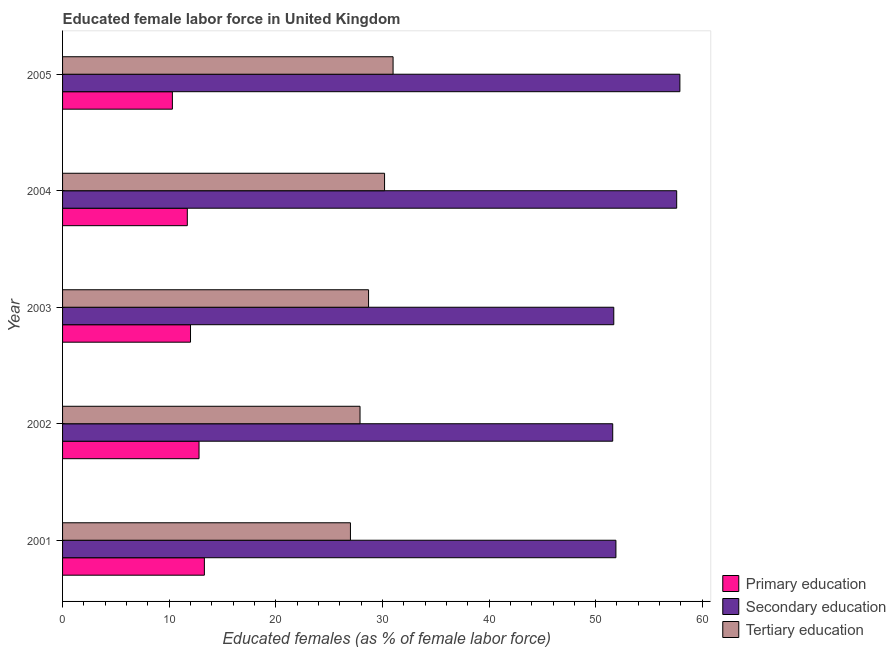How many bars are there on the 2nd tick from the top?
Provide a short and direct response. 3. In how many cases, is the number of bars for a given year not equal to the number of legend labels?
Keep it short and to the point. 0. What is the percentage of female labor force who received primary education in 2005?
Provide a succinct answer. 10.3. Across all years, what is the maximum percentage of female labor force who received secondary education?
Give a very brief answer. 57.9. Across all years, what is the minimum percentage of female labor force who received tertiary education?
Make the answer very short. 27. In which year was the percentage of female labor force who received primary education maximum?
Provide a short and direct response. 2001. In which year was the percentage of female labor force who received secondary education minimum?
Provide a short and direct response. 2002. What is the total percentage of female labor force who received tertiary education in the graph?
Provide a short and direct response. 144.8. What is the difference between the percentage of female labor force who received primary education in 2003 and the percentage of female labor force who received secondary education in 2005?
Keep it short and to the point. -45.9. What is the average percentage of female labor force who received tertiary education per year?
Offer a terse response. 28.96. In the year 2001, what is the difference between the percentage of female labor force who received tertiary education and percentage of female labor force who received primary education?
Keep it short and to the point. 13.7. In how many years, is the percentage of female labor force who received primary education greater than 58 %?
Your answer should be compact. 0. What is the ratio of the percentage of female labor force who received primary education in 2001 to that in 2005?
Provide a succinct answer. 1.29. Is the percentage of female labor force who received primary education in 2002 less than that in 2004?
Ensure brevity in your answer.  No. Is the difference between the percentage of female labor force who received primary education in 2001 and 2004 greater than the difference between the percentage of female labor force who received tertiary education in 2001 and 2004?
Your answer should be compact. Yes. What does the 1st bar from the top in 2003 represents?
Ensure brevity in your answer.  Tertiary education. What does the 3rd bar from the bottom in 2003 represents?
Provide a succinct answer. Tertiary education. How many bars are there?
Give a very brief answer. 15. Are all the bars in the graph horizontal?
Keep it short and to the point. Yes. Does the graph contain grids?
Offer a very short reply. No. How many legend labels are there?
Provide a succinct answer. 3. What is the title of the graph?
Ensure brevity in your answer.  Educated female labor force in United Kingdom. Does "Oil" appear as one of the legend labels in the graph?
Offer a terse response. No. What is the label or title of the X-axis?
Offer a very short reply. Educated females (as % of female labor force). What is the Educated females (as % of female labor force) of Primary education in 2001?
Provide a succinct answer. 13.3. What is the Educated females (as % of female labor force) of Secondary education in 2001?
Offer a terse response. 51.9. What is the Educated females (as % of female labor force) of Tertiary education in 2001?
Your answer should be very brief. 27. What is the Educated females (as % of female labor force) in Primary education in 2002?
Your answer should be very brief. 12.8. What is the Educated females (as % of female labor force) of Secondary education in 2002?
Offer a terse response. 51.6. What is the Educated females (as % of female labor force) in Tertiary education in 2002?
Provide a short and direct response. 27.9. What is the Educated females (as % of female labor force) in Primary education in 2003?
Make the answer very short. 12. What is the Educated females (as % of female labor force) in Secondary education in 2003?
Keep it short and to the point. 51.7. What is the Educated females (as % of female labor force) of Tertiary education in 2003?
Provide a succinct answer. 28.7. What is the Educated females (as % of female labor force) in Primary education in 2004?
Ensure brevity in your answer.  11.7. What is the Educated females (as % of female labor force) of Secondary education in 2004?
Offer a terse response. 57.6. What is the Educated females (as % of female labor force) of Tertiary education in 2004?
Offer a terse response. 30.2. What is the Educated females (as % of female labor force) of Primary education in 2005?
Offer a terse response. 10.3. What is the Educated females (as % of female labor force) of Secondary education in 2005?
Keep it short and to the point. 57.9. Across all years, what is the maximum Educated females (as % of female labor force) in Primary education?
Make the answer very short. 13.3. Across all years, what is the maximum Educated females (as % of female labor force) in Secondary education?
Provide a short and direct response. 57.9. Across all years, what is the minimum Educated females (as % of female labor force) of Primary education?
Provide a succinct answer. 10.3. Across all years, what is the minimum Educated females (as % of female labor force) in Secondary education?
Your answer should be compact. 51.6. Across all years, what is the minimum Educated females (as % of female labor force) of Tertiary education?
Make the answer very short. 27. What is the total Educated females (as % of female labor force) of Primary education in the graph?
Make the answer very short. 60.1. What is the total Educated females (as % of female labor force) of Secondary education in the graph?
Offer a terse response. 270.7. What is the total Educated females (as % of female labor force) in Tertiary education in the graph?
Your response must be concise. 144.8. What is the difference between the Educated females (as % of female labor force) of Secondary education in 2001 and that in 2002?
Give a very brief answer. 0.3. What is the difference between the Educated females (as % of female labor force) of Primary education in 2001 and that in 2003?
Your answer should be compact. 1.3. What is the difference between the Educated females (as % of female labor force) in Secondary education in 2001 and that in 2003?
Your answer should be very brief. 0.2. What is the difference between the Educated females (as % of female labor force) of Primary education in 2001 and that in 2004?
Make the answer very short. 1.6. What is the difference between the Educated females (as % of female labor force) in Secondary education in 2001 and that in 2004?
Provide a short and direct response. -5.7. What is the difference between the Educated females (as % of female labor force) in Primary education in 2001 and that in 2005?
Your answer should be very brief. 3. What is the difference between the Educated females (as % of female labor force) of Tertiary education in 2001 and that in 2005?
Offer a very short reply. -4. What is the difference between the Educated females (as % of female labor force) of Primary education in 2002 and that in 2003?
Make the answer very short. 0.8. What is the difference between the Educated females (as % of female labor force) in Secondary education in 2002 and that in 2003?
Keep it short and to the point. -0.1. What is the difference between the Educated females (as % of female labor force) of Primary education in 2002 and that in 2004?
Ensure brevity in your answer.  1.1. What is the difference between the Educated females (as % of female labor force) in Primary education in 2002 and that in 2005?
Give a very brief answer. 2.5. What is the difference between the Educated females (as % of female labor force) in Primary education in 2003 and that in 2004?
Offer a very short reply. 0.3. What is the difference between the Educated females (as % of female labor force) in Secondary education in 2003 and that in 2004?
Offer a terse response. -5.9. What is the difference between the Educated females (as % of female labor force) of Primary education in 2003 and that in 2005?
Provide a short and direct response. 1.7. What is the difference between the Educated females (as % of female labor force) in Tertiary education in 2003 and that in 2005?
Your answer should be very brief. -2.3. What is the difference between the Educated females (as % of female labor force) of Primary education in 2004 and that in 2005?
Provide a short and direct response. 1.4. What is the difference between the Educated females (as % of female labor force) of Secondary education in 2004 and that in 2005?
Offer a terse response. -0.3. What is the difference between the Educated females (as % of female labor force) of Primary education in 2001 and the Educated females (as % of female labor force) of Secondary education in 2002?
Provide a succinct answer. -38.3. What is the difference between the Educated females (as % of female labor force) of Primary education in 2001 and the Educated females (as % of female labor force) of Tertiary education in 2002?
Provide a short and direct response. -14.6. What is the difference between the Educated females (as % of female labor force) in Primary education in 2001 and the Educated females (as % of female labor force) in Secondary education in 2003?
Your answer should be very brief. -38.4. What is the difference between the Educated females (as % of female labor force) in Primary education in 2001 and the Educated females (as % of female labor force) in Tertiary education in 2003?
Your response must be concise. -15.4. What is the difference between the Educated females (as % of female labor force) in Secondary education in 2001 and the Educated females (as % of female labor force) in Tertiary education in 2003?
Offer a very short reply. 23.2. What is the difference between the Educated females (as % of female labor force) in Primary education in 2001 and the Educated females (as % of female labor force) in Secondary education in 2004?
Your response must be concise. -44.3. What is the difference between the Educated females (as % of female labor force) of Primary education in 2001 and the Educated females (as % of female labor force) of Tertiary education in 2004?
Provide a succinct answer. -16.9. What is the difference between the Educated females (as % of female labor force) in Secondary education in 2001 and the Educated females (as % of female labor force) in Tertiary education in 2004?
Your response must be concise. 21.7. What is the difference between the Educated females (as % of female labor force) of Primary education in 2001 and the Educated females (as % of female labor force) of Secondary education in 2005?
Offer a terse response. -44.6. What is the difference between the Educated females (as % of female labor force) in Primary education in 2001 and the Educated females (as % of female labor force) in Tertiary education in 2005?
Offer a terse response. -17.7. What is the difference between the Educated females (as % of female labor force) of Secondary education in 2001 and the Educated females (as % of female labor force) of Tertiary education in 2005?
Your answer should be very brief. 20.9. What is the difference between the Educated females (as % of female labor force) in Primary education in 2002 and the Educated females (as % of female labor force) in Secondary education in 2003?
Offer a terse response. -38.9. What is the difference between the Educated females (as % of female labor force) of Primary education in 2002 and the Educated females (as % of female labor force) of Tertiary education in 2003?
Provide a short and direct response. -15.9. What is the difference between the Educated females (as % of female labor force) of Secondary education in 2002 and the Educated females (as % of female labor force) of Tertiary education in 2003?
Offer a very short reply. 22.9. What is the difference between the Educated females (as % of female labor force) in Primary education in 2002 and the Educated females (as % of female labor force) in Secondary education in 2004?
Your response must be concise. -44.8. What is the difference between the Educated females (as % of female labor force) of Primary education in 2002 and the Educated females (as % of female labor force) of Tertiary education in 2004?
Offer a very short reply. -17.4. What is the difference between the Educated females (as % of female labor force) in Secondary education in 2002 and the Educated females (as % of female labor force) in Tertiary education in 2004?
Provide a short and direct response. 21.4. What is the difference between the Educated females (as % of female labor force) in Primary education in 2002 and the Educated females (as % of female labor force) in Secondary education in 2005?
Offer a terse response. -45.1. What is the difference between the Educated females (as % of female labor force) of Primary education in 2002 and the Educated females (as % of female labor force) of Tertiary education in 2005?
Give a very brief answer. -18.2. What is the difference between the Educated females (as % of female labor force) of Secondary education in 2002 and the Educated females (as % of female labor force) of Tertiary education in 2005?
Your answer should be very brief. 20.6. What is the difference between the Educated females (as % of female labor force) of Primary education in 2003 and the Educated females (as % of female labor force) of Secondary education in 2004?
Your answer should be compact. -45.6. What is the difference between the Educated females (as % of female labor force) of Primary education in 2003 and the Educated females (as % of female labor force) of Tertiary education in 2004?
Offer a very short reply. -18.2. What is the difference between the Educated females (as % of female labor force) of Primary education in 2003 and the Educated females (as % of female labor force) of Secondary education in 2005?
Make the answer very short. -45.9. What is the difference between the Educated females (as % of female labor force) in Primary education in 2003 and the Educated females (as % of female labor force) in Tertiary education in 2005?
Your response must be concise. -19. What is the difference between the Educated females (as % of female labor force) of Secondary education in 2003 and the Educated females (as % of female labor force) of Tertiary education in 2005?
Your response must be concise. 20.7. What is the difference between the Educated females (as % of female labor force) of Primary education in 2004 and the Educated females (as % of female labor force) of Secondary education in 2005?
Your answer should be very brief. -46.2. What is the difference between the Educated females (as % of female labor force) in Primary education in 2004 and the Educated females (as % of female labor force) in Tertiary education in 2005?
Offer a very short reply. -19.3. What is the difference between the Educated females (as % of female labor force) of Secondary education in 2004 and the Educated females (as % of female labor force) of Tertiary education in 2005?
Give a very brief answer. 26.6. What is the average Educated females (as % of female labor force) of Primary education per year?
Provide a short and direct response. 12.02. What is the average Educated females (as % of female labor force) of Secondary education per year?
Keep it short and to the point. 54.14. What is the average Educated females (as % of female labor force) of Tertiary education per year?
Your response must be concise. 28.96. In the year 2001, what is the difference between the Educated females (as % of female labor force) of Primary education and Educated females (as % of female labor force) of Secondary education?
Your answer should be very brief. -38.6. In the year 2001, what is the difference between the Educated females (as % of female labor force) in Primary education and Educated females (as % of female labor force) in Tertiary education?
Provide a short and direct response. -13.7. In the year 2001, what is the difference between the Educated females (as % of female labor force) of Secondary education and Educated females (as % of female labor force) of Tertiary education?
Your answer should be very brief. 24.9. In the year 2002, what is the difference between the Educated females (as % of female labor force) in Primary education and Educated females (as % of female labor force) in Secondary education?
Ensure brevity in your answer.  -38.8. In the year 2002, what is the difference between the Educated females (as % of female labor force) in Primary education and Educated females (as % of female labor force) in Tertiary education?
Make the answer very short. -15.1. In the year 2002, what is the difference between the Educated females (as % of female labor force) in Secondary education and Educated females (as % of female labor force) in Tertiary education?
Your answer should be compact. 23.7. In the year 2003, what is the difference between the Educated females (as % of female labor force) in Primary education and Educated females (as % of female labor force) in Secondary education?
Provide a short and direct response. -39.7. In the year 2003, what is the difference between the Educated females (as % of female labor force) in Primary education and Educated females (as % of female labor force) in Tertiary education?
Keep it short and to the point. -16.7. In the year 2004, what is the difference between the Educated females (as % of female labor force) in Primary education and Educated females (as % of female labor force) in Secondary education?
Provide a short and direct response. -45.9. In the year 2004, what is the difference between the Educated females (as % of female labor force) in Primary education and Educated females (as % of female labor force) in Tertiary education?
Your response must be concise. -18.5. In the year 2004, what is the difference between the Educated females (as % of female labor force) of Secondary education and Educated females (as % of female labor force) of Tertiary education?
Offer a terse response. 27.4. In the year 2005, what is the difference between the Educated females (as % of female labor force) of Primary education and Educated females (as % of female labor force) of Secondary education?
Keep it short and to the point. -47.6. In the year 2005, what is the difference between the Educated females (as % of female labor force) in Primary education and Educated females (as % of female labor force) in Tertiary education?
Your response must be concise. -20.7. In the year 2005, what is the difference between the Educated females (as % of female labor force) of Secondary education and Educated females (as % of female labor force) of Tertiary education?
Offer a very short reply. 26.9. What is the ratio of the Educated females (as % of female labor force) in Primary education in 2001 to that in 2002?
Give a very brief answer. 1.04. What is the ratio of the Educated females (as % of female labor force) in Secondary education in 2001 to that in 2002?
Your answer should be very brief. 1.01. What is the ratio of the Educated females (as % of female labor force) of Tertiary education in 2001 to that in 2002?
Offer a very short reply. 0.97. What is the ratio of the Educated females (as % of female labor force) of Primary education in 2001 to that in 2003?
Your answer should be compact. 1.11. What is the ratio of the Educated females (as % of female labor force) of Tertiary education in 2001 to that in 2003?
Your answer should be very brief. 0.94. What is the ratio of the Educated females (as % of female labor force) of Primary education in 2001 to that in 2004?
Provide a short and direct response. 1.14. What is the ratio of the Educated females (as % of female labor force) of Secondary education in 2001 to that in 2004?
Your answer should be very brief. 0.9. What is the ratio of the Educated females (as % of female labor force) of Tertiary education in 2001 to that in 2004?
Keep it short and to the point. 0.89. What is the ratio of the Educated females (as % of female labor force) of Primary education in 2001 to that in 2005?
Offer a terse response. 1.29. What is the ratio of the Educated females (as % of female labor force) in Secondary education in 2001 to that in 2005?
Your answer should be compact. 0.9. What is the ratio of the Educated females (as % of female labor force) in Tertiary education in 2001 to that in 2005?
Provide a short and direct response. 0.87. What is the ratio of the Educated females (as % of female labor force) of Primary education in 2002 to that in 2003?
Provide a succinct answer. 1.07. What is the ratio of the Educated females (as % of female labor force) in Secondary education in 2002 to that in 2003?
Provide a succinct answer. 1. What is the ratio of the Educated females (as % of female labor force) of Tertiary education in 2002 to that in 2003?
Your answer should be compact. 0.97. What is the ratio of the Educated females (as % of female labor force) of Primary education in 2002 to that in 2004?
Your response must be concise. 1.09. What is the ratio of the Educated females (as % of female labor force) in Secondary education in 2002 to that in 2004?
Ensure brevity in your answer.  0.9. What is the ratio of the Educated females (as % of female labor force) of Tertiary education in 2002 to that in 2004?
Offer a terse response. 0.92. What is the ratio of the Educated females (as % of female labor force) in Primary education in 2002 to that in 2005?
Provide a succinct answer. 1.24. What is the ratio of the Educated females (as % of female labor force) in Secondary education in 2002 to that in 2005?
Keep it short and to the point. 0.89. What is the ratio of the Educated females (as % of female labor force) in Primary education in 2003 to that in 2004?
Give a very brief answer. 1.03. What is the ratio of the Educated females (as % of female labor force) in Secondary education in 2003 to that in 2004?
Ensure brevity in your answer.  0.9. What is the ratio of the Educated females (as % of female labor force) in Tertiary education in 2003 to that in 2004?
Your response must be concise. 0.95. What is the ratio of the Educated females (as % of female labor force) of Primary education in 2003 to that in 2005?
Offer a terse response. 1.17. What is the ratio of the Educated females (as % of female labor force) of Secondary education in 2003 to that in 2005?
Make the answer very short. 0.89. What is the ratio of the Educated females (as % of female labor force) of Tertiary education in 2003 to that in 2005?
Provide a short and direct response. 0.93. What is the ratio of the Educated females (as % of female labor force) of Primary education in 2004 to that in 2005?
Your response must be concise. 1.14. What is the ratio of the Educated females (as % of female labor force) in Secondary education in 2004 to that in 2005?
Your answer should be compact. 0.99. What is the ratio of the Educated females (as % of female labor force) in Tertiary education in 2004 to that in 2005?
Your answer should be compact. 0.97. What is the difference between the highest and the second highest Educated females (as % of female labor force) of Primary education?
Ensure brevity in your answer.  0.5. What is the difference between the highest and the lowest Educated females (as % of female labor force) of Secondary education?
Offer a terse response. 6.3. 